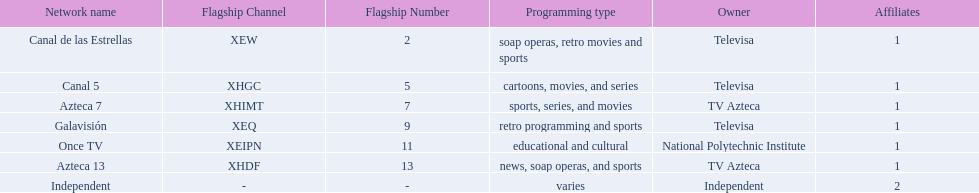Name a station that shows sports but is not televisa. Azteca 7. 